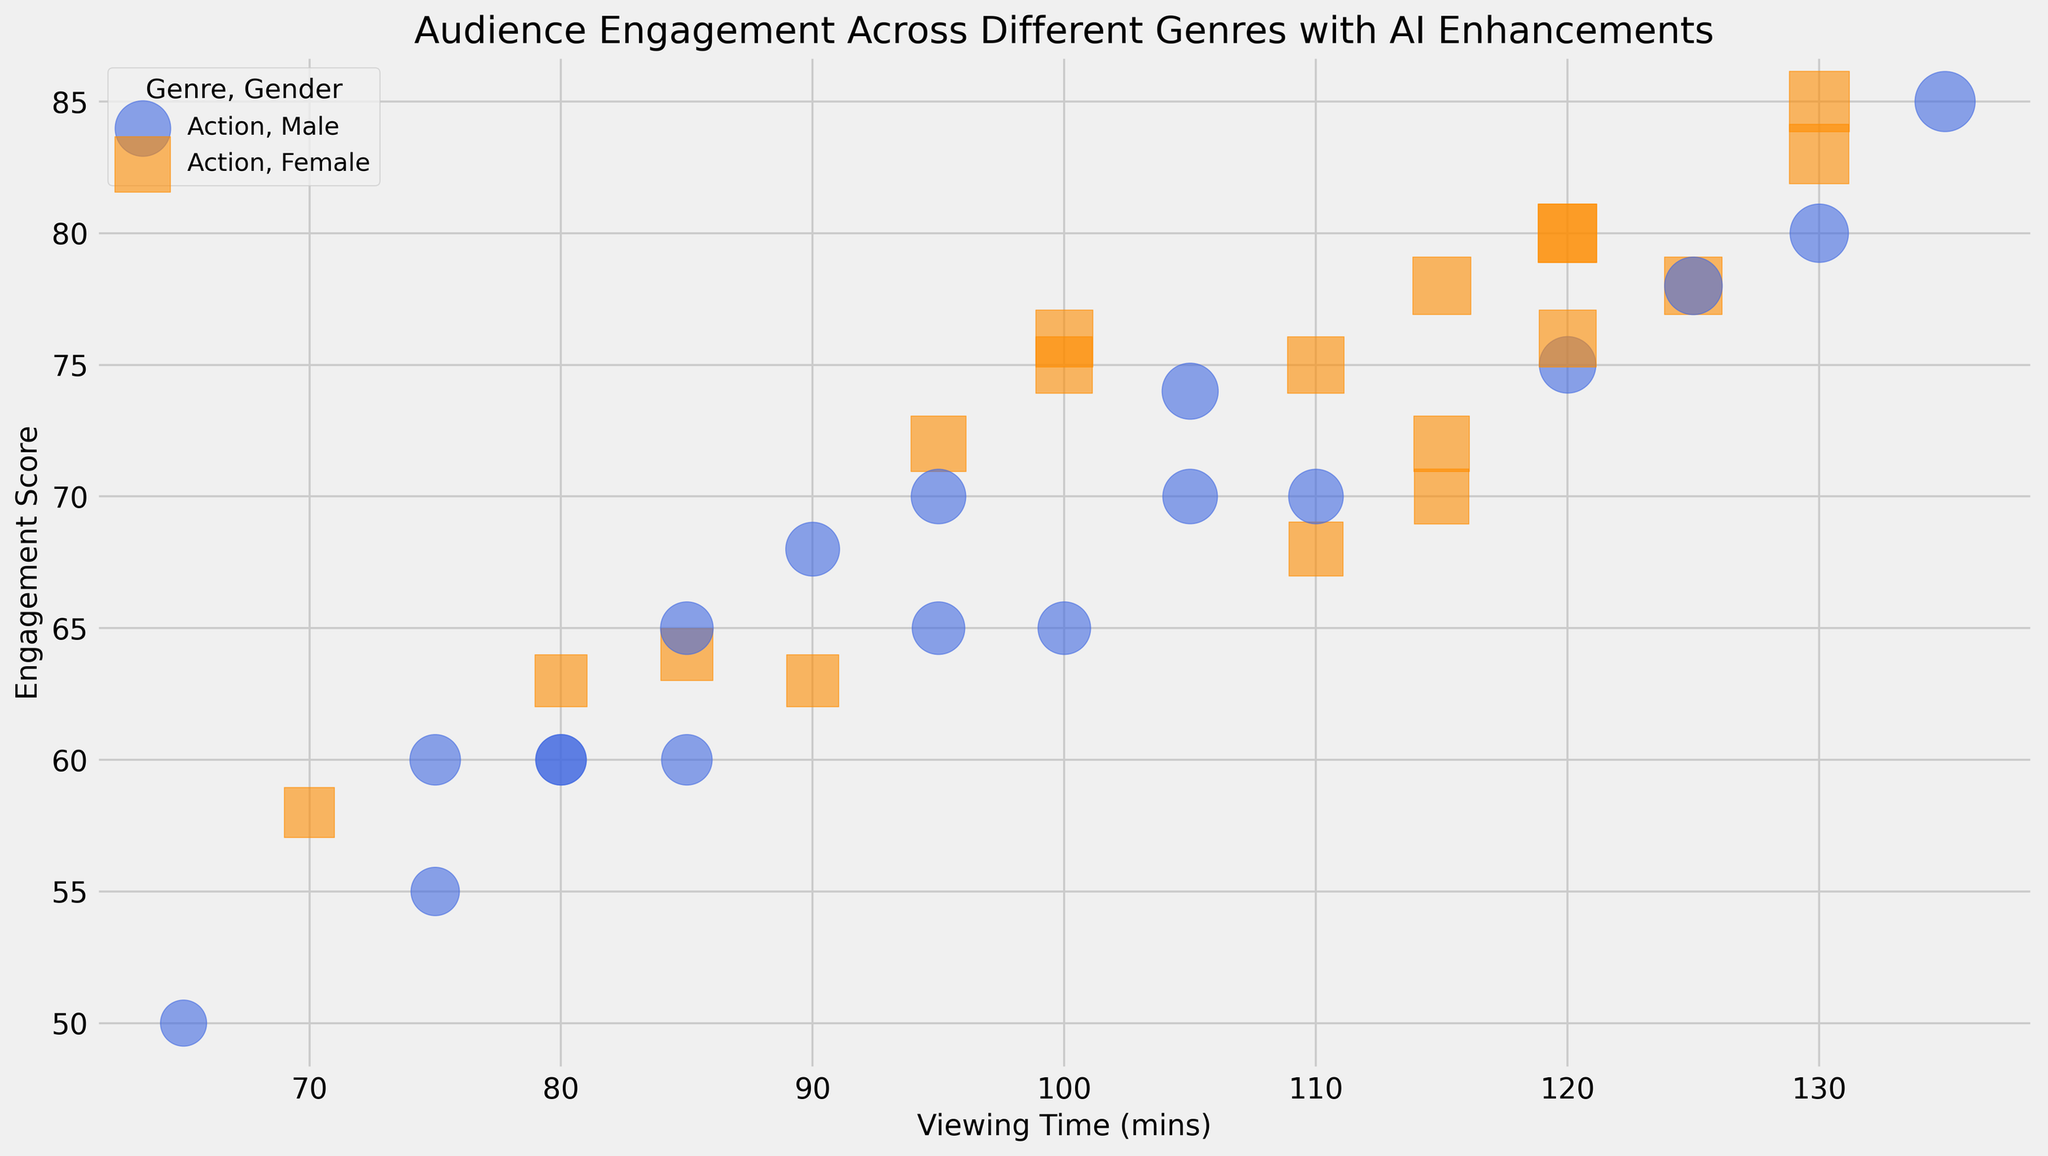What genre and gender combination has the highest engagement score for the 25-34 age group? Look at each genre and gender combination for the 25-34 age group. Observe the engagement scores and compare. Sci-Fi, Male and Romance, Female both have the engagement score of 85, tied for the highest.
Answer: Sci-Fi, Male and Romance, Female Which genre has the lowest average engagement score for the 35-44 age group? Calculate the average engagement score for each genre in the 35-44 age group. Action: (65+68)/2, Drama: (60+63)/2, Comedy: (60+64)/2, Sci-Fi: (70+72)/2, Horror: (60+58)/2, Romance: (50+78)/2. The lowest average engagement score is from Horror, (60+58)/2=59.
Answer: Horror What is the difference between the highest and lowest engagement scores within the Romance genre for all age groups? First, identify the highest and lowest engagement scores within the Romance genre for all age groups. The highest is 85 (25-34, Female) and the lowest is 50 (35-44, Male). The difference is 85 - 50.
Answer: 35 Which age group has a higher viewing time for Sci-Fi, 18-24 or 35-44? Compare the viewing times for the 18-24 and 35-44 age groups in the Sci-Fi genre. 18-24 group: 125 (Male), 120 (Female). 35-44 group: 110 (Male), 115 (Female). Average for 18-24 is (125+120)/2 = 122.5, and for 35-44 it is (110+115)/2 = 112.5. 18-24 has a higher viewing time.
Answer: 18-24 Which has a higher engagement score in the Action genre, males aged 18-24 or females aged 25-34? Compare the engagement scores between males aged 18-24 (75) and females aged 25-34 (78) in the Action genre. The engagement score for females aged 25-34 is higher.
Answer: Females aged 25-34 In the Comedy genre, what is the sum of the engagement scores for all age groups and genders combined? Sum the engagement scores for all age groups and genders in the Comedy genre. 68 (18-24, Male) + 72 (18-24, Female) + 74 (25-34, Male) + 76 (25-34, Female) + 60 (35-44, Male) + 64 (35-44, Female) = 414.
Answer: 414 What color represents female viewers in the plot? Based on the plot’s gender color coding, identify which color is used for female viewers.
Answer: Darkorange Which age group and gender have the smallest bubble size in the Action genre? Find the smallest engagement score in the Action genre, as bubble size corresponds to engagement score. For Action, the smallest engagement score is 65 (35-44, Male) and 68 (35-44, Female). Since both are small, the male has the smallest bubble size (65).
Answer: 35-44, Male 